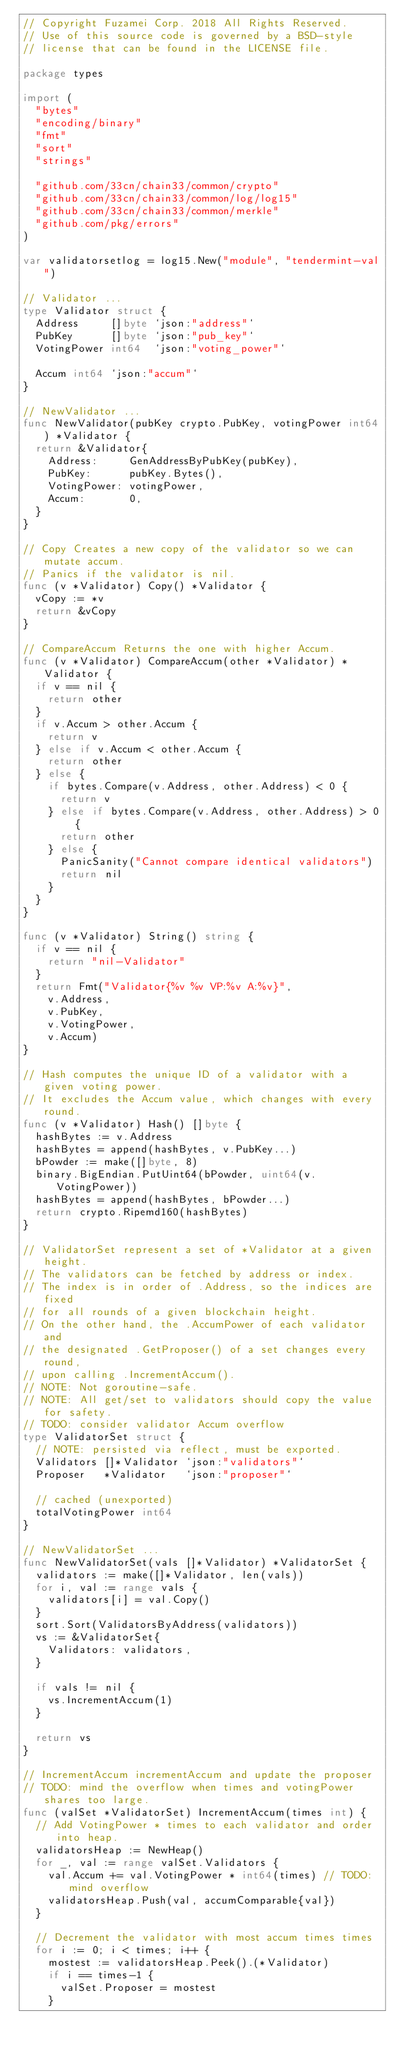<code> <loc_0><loc_0><loc_500><loc_500><_Go_>// Copyright Fuzamei Corp. 2018 All Rights Reserved.
// Use of this source code is governed by a BSD-style
// license that can be found in the LICENSE file.

package types

import (
	"bytes"
	"encoding/binary"
	"fmt"
	"sort"
	"strings"

	"github.com/33cn/chain33/common/crypto"
	"github.com/33cn/chain33/common/log/log15"
	"github.com/33cn/chain33/common/merkle"
	"github.com/pkg/errors"
)

var validatorsetlog = log15.New("module", "tendermint-val")

// Validator ...
type Validator struct {
	Address     []byte `json:"address"`
	PubKey      []byte `json:"pub_key"`
	VotingPower int64  `json:"voting_power"`

	Accum int64 `json:"accum"`
}

// NewValidator ...
func NewValidator(pubKey crypto.PubKey, votingPower int64) *Validator {
	return &Validator{
		Address:     GenAddressByPubKey(pubKey),
		PubKey:      pubKey.Bytes(),
		VotingPower: votingPower,
		Accum:       0,
	}
}

// Copy Creates a new copy of the validator so we can mutate accum.
// Panics if the validator is nil.
func (v *Validator) Copy() *Validator {
	vCopy := *v
	return &vCopy
}

// CompareAccum Returns the one with higher Accum.
func (v *Validator) CompareAccum(other *Validator) *Validator {
	if v == nil {
		return other
	}
	if v.Accum > other.Accum {
		return v
	} else if v.Accum < other.Accum {
		return other
	} else {
		if bytes.Compare(v.Address, other.Address) < 0 {
			return v
		} else if bytes.Compare(v.Address, other.Address) > 0 {
			return other
		} else {
			PanicSanity("Cannot compare identical validators")
			return nil
		}
	}
}

func (v *Validator) String() string {
	if v == nil {
		return "nil-Validator"
	}
	return Fmt("Validator{%v %v VP:%v A:%v}",
		v.Address,
		v.PubKey,
		v.VotingPower,
		v.Accum)
}

// Hash computes the unique ID of a validator with a given voting power.
// It excludes the Accum value, which changes with every round.
func (v *Validator) Hash() []byte {
	hashBytes := v.Address
	hashBytes = append(hashBytes, v.PubKey...)
	bPowder := make([]byte, 8)
	binary.BigEndian.PutUint64(bPowder, uint64(v.VotingPower))
	hashBytes = append(hashBytes, bPowder...)
	return crypto.Ripemd160(hashBytes)
}

// ValidatorSet represent a set of *Validator at a given height.
// The validators can be fetched by address or index.
// The index is in order of .Address, so the indices are fixed
// for all rounds of a given blockchain height.
// On the other hand, the .AccumPower of each validator and
// the designated .GetProposer() of a set changes every round,
// upon calling .IncrementAccum().
// NOTE: Not goroutine-safe.
// NOTE: All get/set to validators should copy the value for safety.
// TODO: consider validator Accum overflow
type ValidatorSet struct {
	// NOTE: persisted via reflect, must be exported.
	Validators []*Validator `json:"validators"`
	Proposer   *Validator   `json:"proposer"`

	// cached (unexported)
	totalVotingPower int64
}

// NewValidatorSet ...
func NewValidatorSet(vals []*Validator) *ValidatorSet {
	validators := make([]*Validator, len(vals))
	for i, val := range vals {
		validators[i] = val.Copy()
	}
	sort.Sort(ValidatorsByAddress(validators))
	vs := &ValidatorSet{
		Validators: validators,
	}

	if vals != nil {
		vs.IncrementAccum(1)
	}

	return vs
}

// IncrementAccum incrementAccum and update the proposer
// TODO: mind the overflow when times and votingPower shares too large.
func (valSet *ValidatorSet) IncrementAccum(times int) {
	// Add VotingPower * times to each validator and order into heap.
	validatorsHeap := NewHeap()
	for _, val := range valSet.Validators {
		val.Accum += val.VotingPower * int64(times) // TODO: mind overflow
		validatorsHeap.Push(val, accumComparable{val})
	}

	// Decrement the validator with most accum times times
	for i := 0; i < times; i++ {
		mostest := validatorsHeap.Peek().(*Validator)
		if i == times-1 {
			valSet.Proposer = mostest
		}</code> 